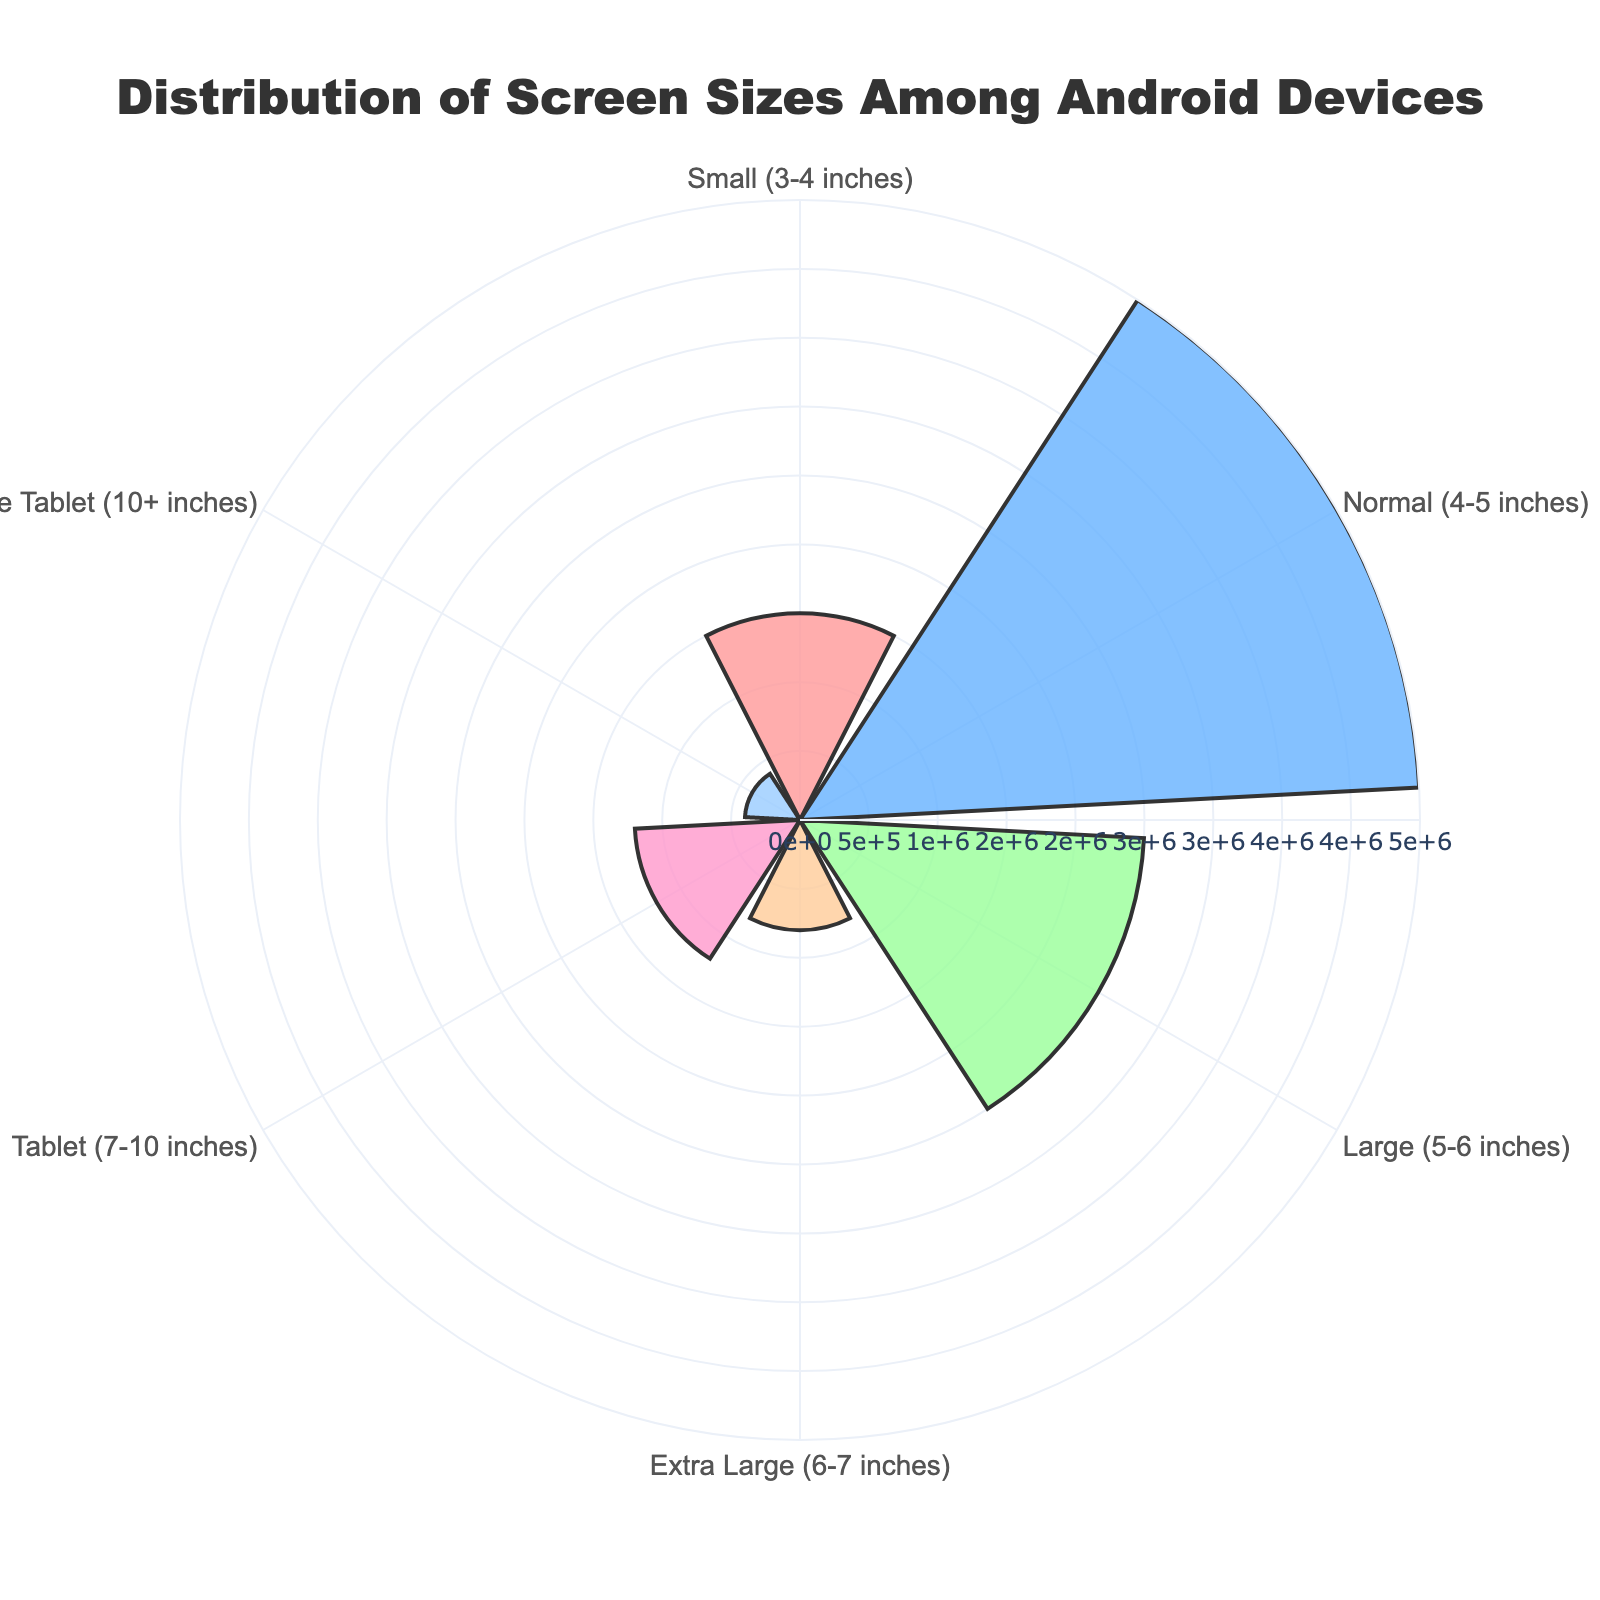what is the title of the chart? The title is usually displayed at the top of the chart. In this case, it is "Distribution of Screen Sizes Among Android Devices" as specified in the code.
Answer: Distribution of Screen Sizes Among Android Devices Which screen size category has the highest number of devices? By looking at the lengths of the bars or the radial distance in the rose chart, the "Normal (4-5 inches)" category has the longest bar, indicating it has the highest number of devices.
Answer: Normal (4-5 inches) What color is used for the Small (3-4 inches) screen size category? The colors of the bars are defined in the code. The "Small (3-4 inches)" screen size category is assigned the color '#FF9999', which is a shade of pink.
Answer: pink Which screen size group has the second smallest number of devices? By analyzing the lengths of the bars, the "Extra Large Tablet (10+ inches)" has 400,000 devices which is the second smallest, larger only than "Tablet (7-10 inches)" with 1,200,000 devices.
Answer: Extra Large Tablet (10+ inches) What percentage of the total number of devices is in the Large (5-6 inches) screen size category? To find the percentage, sum up all the device counts: 1500000 + 4500000 + 2500000 + 800000 + 1200000 + 400000 = 10800000. Then, divide the number of devices in the Large category by the total and multiply by 100: (2500000/10800000) * 100.
Answer: 23.15% How does the number of devices in the Tablet (7-10 inches) category compare to those in the Small (3-4 inches) category? The bar for "Tablet (7-10 inches)" is shorter than "Small (3-4 inches)", indicating there are fewer devices in the former category. Specifically, the numbers are 1200000 for Tablet and 1500000 for Small, so the Small category has more devices.
Answer: Small (3-4 inches) has more Which screen size category has 1.2 million devices? Observe the radial distance in the rose chart; the "Tablet (7-10 inches)" category aligns with 1.2 million devices.
Answer: Tablet (7-10 inches) What is the total number of devices represented in the rose chart? Sum the number of devices in each screen size category: 1500000 + 4500000 + 2500000 + 800000 + 1200000 + 400000.
Answer: 10800000 Are the colors of the chart uniform for all categories? The chart uses different colors for each screen size category, as evident from the visual appearance of various colored bars in the rose chart.
Answer: No What is the disparity between the number of devices in 'Normal (4-5 inches)' and 'Extra Large (6-7 inches)' screen sizes? Subtract the number of devices in 'Extra Large (6-7 inches)' from 'Normal (4-5 inches)'. Given 4500000 for Normal and 800000 for Extra Large: 4500000 - 800000.
Answer: 3700000 